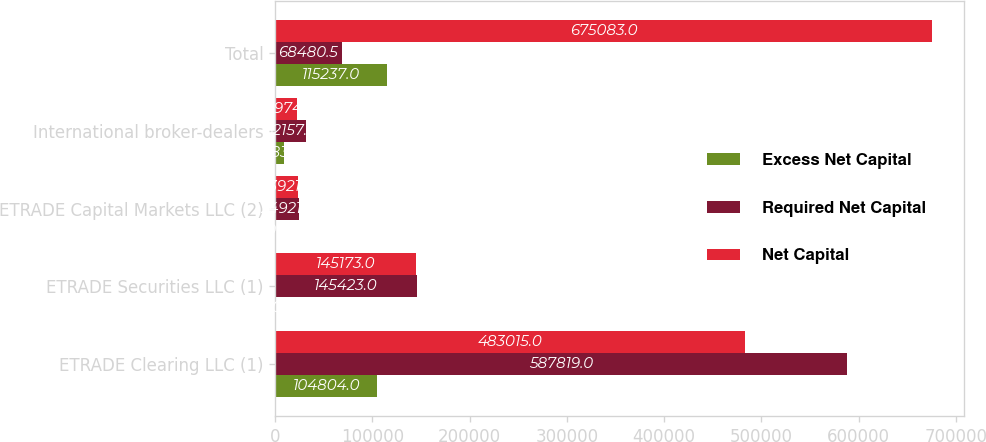Convert chart to OTSL. <chart><loc_0><loc_0><loc_500><loc_500><stacked_bar_chart><ecel><fcel>ETRADE Clearing LLC (1)<fcel>ETRADE Securities LLC (1)<fcel>ETRADE Capital Markets LLC (2)<fcel>International broker-dealers<fcel>Total<nl><fcel>Excess Net Capital<fcel>104804<fcel>250<fcel>1000<fcel>9183<fcel>115237<nl><fcel>Required Net Capital<fcel>587819<fcel>145423<fcel>24921<fcel>32157<fcel>68480.5<nl><fcel>Net Capital<fcel>483015<fcel>145173<fcel>23921<fcel>22974<fcel>675083<nl></chart> 